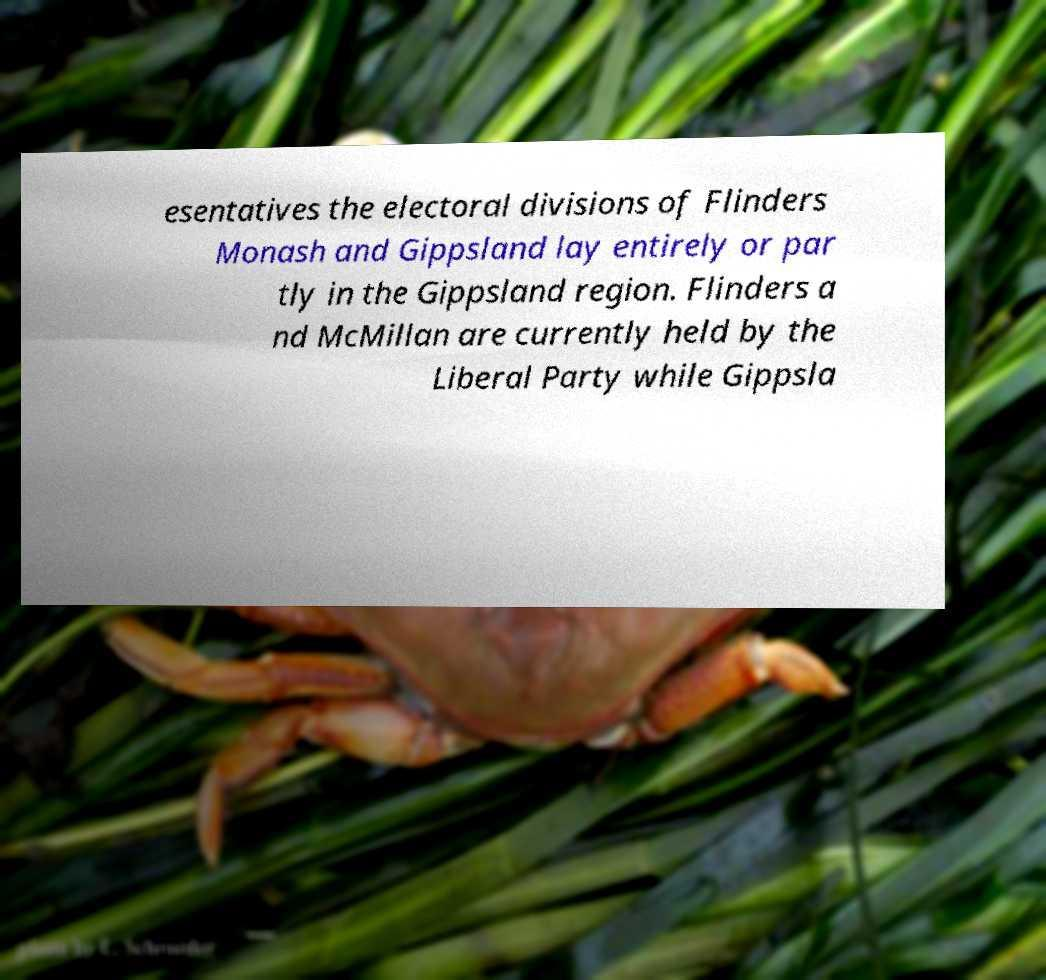Please identify and transcribe the text found in this image. esentatives the electoral divisions of Flinders Monash and Gippsland lay entirely or par tly in the Gippsland region. Flinders a nd McMillan are currently held by the Liberal Party while Gippsla 